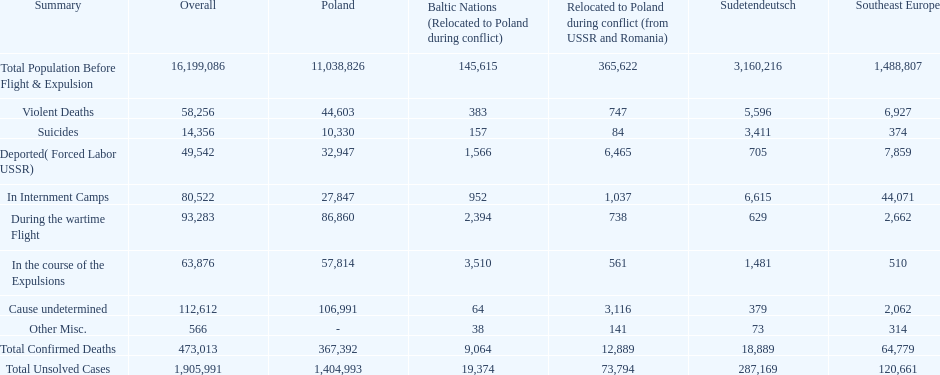Did any location have no violent deaths? No. 